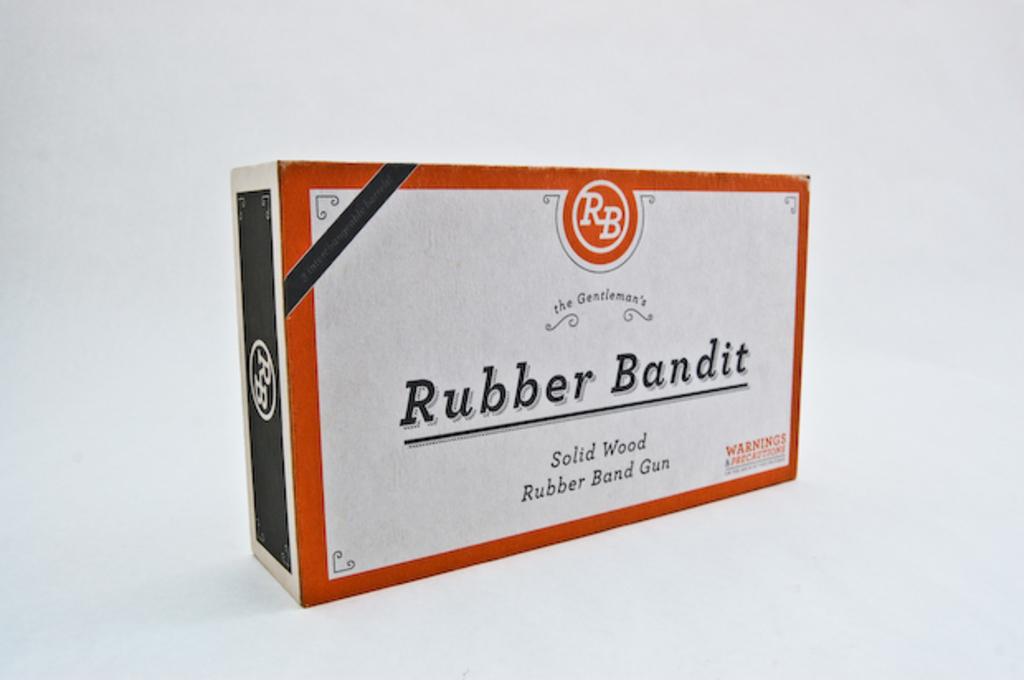What is the rubber band gun made out of?
Keep it short and to the point. Solid wood. What's the company name of the rubber band gun?
Your response must be concise. Rubber bandit. 